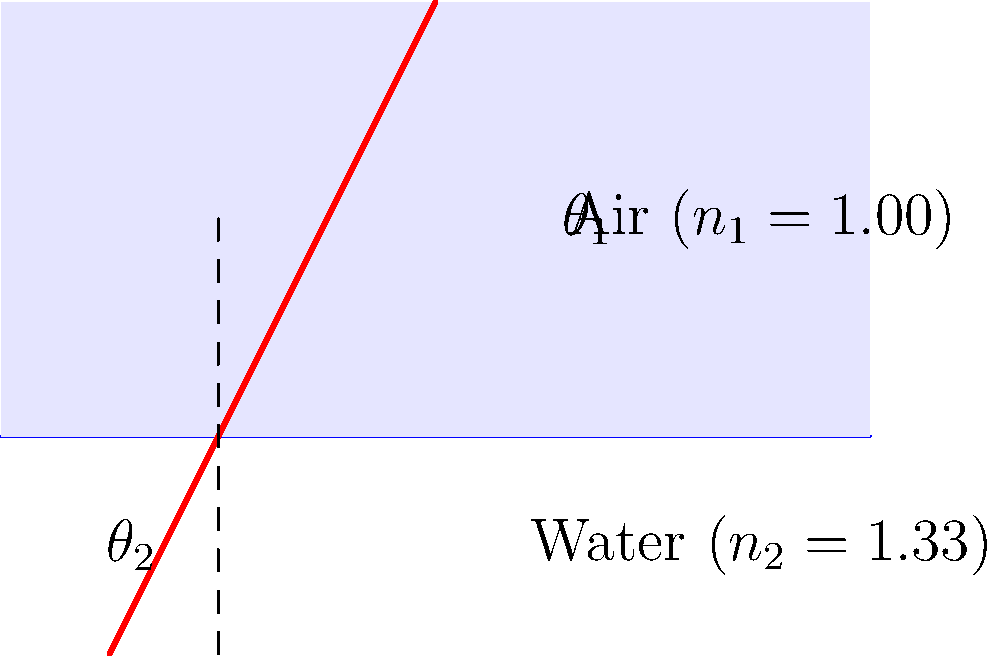A laser beam travels from air into water, as shown in the diagram. If the angle of incidence in air is 45°, what is the angle of refraction in water? (Use $n_{air} = 1.00$ and $n_{water} = 1.33$) To solve this problem, we'll use Snell's law, which relates the angles of incidence and refraction to the refractive indices of the media:

$$n_1 \sin(\theta_1) = n_2 \sin(\theta_2)$$

Where:
$n_1$ = refractive index of air = 1.00
$n_2$ = refractive index of water = 1.33
$\theta_1$ = angle of incidence in air = 45°
$\theta_2$ = angle of refraction in water (unknown)

Steps:
1) Substitute the known values into Snell's law:
   $$(1.00) \sin(45°) = (1.33) \sin(\theta_2)$$

2) Simplify the left side:
   $$\frac{\sqrt{2}}{2} = 1.33 \sin(\theta_2)$$

3) Solve for $\sin(\theta_2)$:
   $$\sin(\theta_2) = \frac{\sqrt{2}}{2 \cdot 1.33} \approx 0.5303$$

4) Take the inverse sine (arcsin) of both sides:
   $$\theta_2 = \arcsin(0.5303) \approx 32.0°$$

This problem demonstrates how light bends when passing between media with different refractive indices, a key concept in optics and cognitive processing of visual information.
Answer: 32.0° 